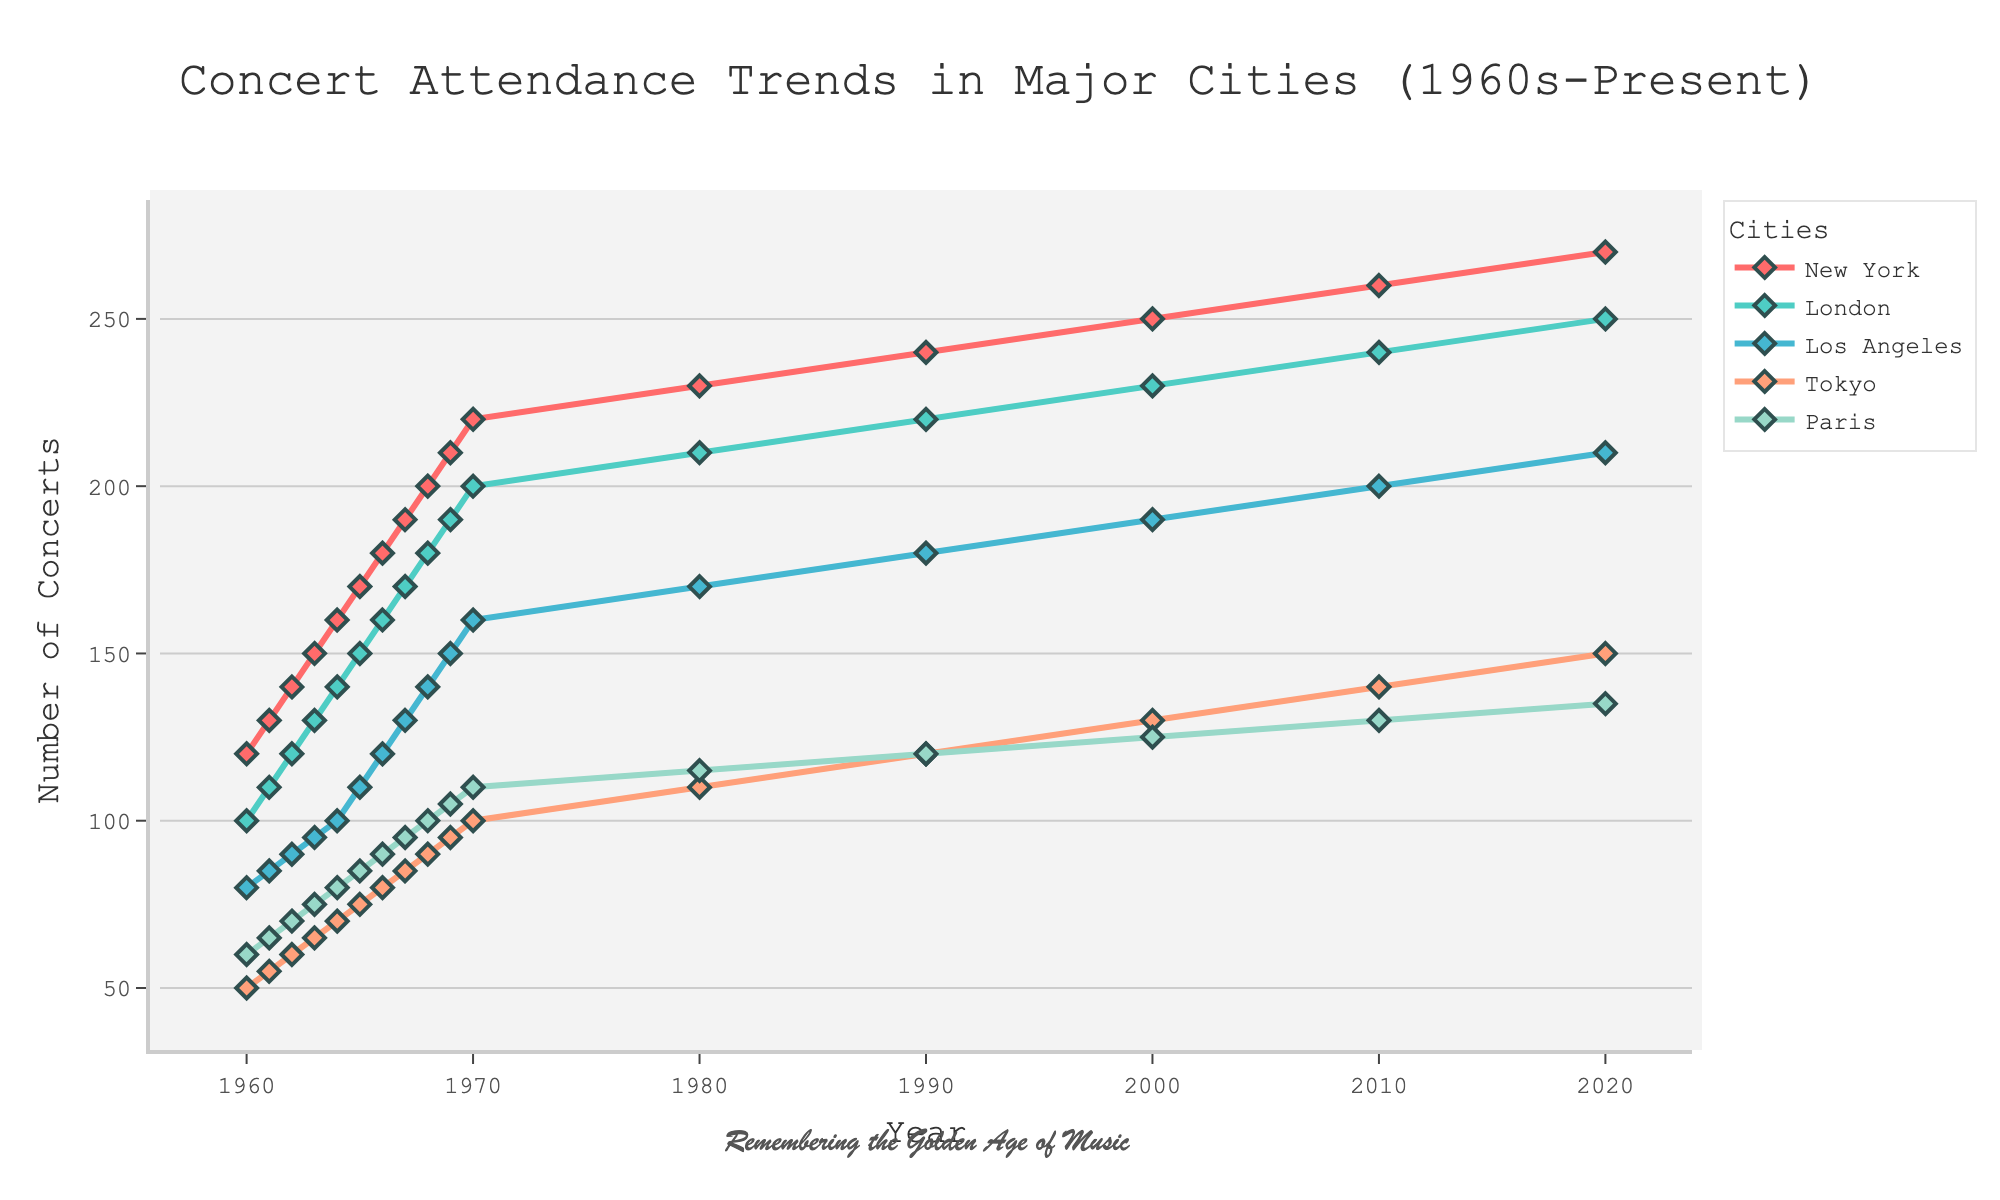what is the total number of concerts held in New York in 2010? Look for the data point corresponding to the year 2010 for New York and read the number of concerts held.
Answer: 260 How did concert attendance in London change from 1960 to 1980? Find the data points for London in both years, subtract the 1960 value from the 1980 value to find the difference.
Answer: Increased by 110 (from 100 to 210) Which city had the highest number of concerts in 2020? Look at the data points for all cities in 2020 and compare the numbers to find the highest.
Answer: New York What is the average number of concerts held in Los Angeles from the 1960s to 1970s? Summing the data points for Los Angeles from 1960 to 1970 and divide by the number of years (11 years).
Answer: (80+85+90+95+100+110+120+130+140+150+160)/11 = 115 Between which two consecutive years did Paris see the largest increase in concert attendance? Find the differences in the number of concerts between consecutive years in Paris and identify the largest increase.
Answer: 1964 to 1965 (from 80 to 85) How does the number of concerts in Tokyo in 2020 compare to the number in 1960? Look at the data points for Tokyo in both years and compare the numbers.
Answer: Tokyo had 100 more concerts in 2020 than in 1960 (50 in 1960 and 150 in 2020) What trend do you observe for concert attendance in major cities from 1960 to present day? Analyze the overall pattern for each city's concert attendance over time.
Answer: An increasing trend for all cities Which decade showed the most growth in concert attendance for New York? Calculate the increases in concert attendance for each decade and find the decade with the largest increase.
Answer: 1960s (from 120 in 1960 to 220 in 1970, increase by 100) What is the rate of increase in concert attendance for Tokyo between 2000 and 2020? Subtract the number of concerts in 2000 from the number in 2020, divide by the number of years (20 years) to find the rate of increase per year.
Answer: (150-130)/20 = 1 concert per year 